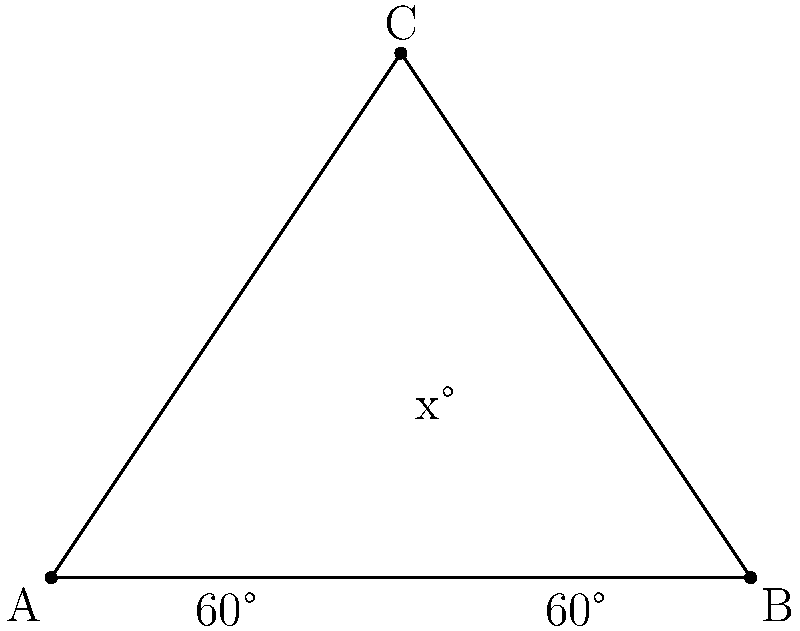For your upcoming concert, you're designing a dramatic lighting effect. Three stage lights are positioned to form a triangle, with two lights on the floor 4 meters apart and one suspended above. The two floor lights are angled 60° upwards. If the suspended light needs to be angled to perfectly bisect the triangle, what should its angle (x°) be set to? Let's approach this step-by-step:

1) First, we recognize that the triangle formed is isosceles. The two base angles are equal (both 60°), so the two sides from the apex to the base are equal.

2) In an isosceles triangle, the line that bisects the apex angle is also the perpendicular bisector of the base and the height of the triangle.

3) This bisector divides the triangle into two right triangles.

4) In one of these right triangles, we know:
   - The angle at the base is 60°
   - The angle at the apex is x/2 (half of what we're looking for)
   - The right angle is 90°

5) In a triangle, all angles must sum to 180°. So:

   $$60° + 90° + \frac{x}{2} = 180°$$

6) Simplifying:

   $$150° + \frac{x}{2} = 180°$$
   $$\frac{x}{2} = 30°$$
   $$x = 60°$$

Therefore, the suspended light should be angled at 60° to perfectly bisect the triangle.
Answer: 60° 